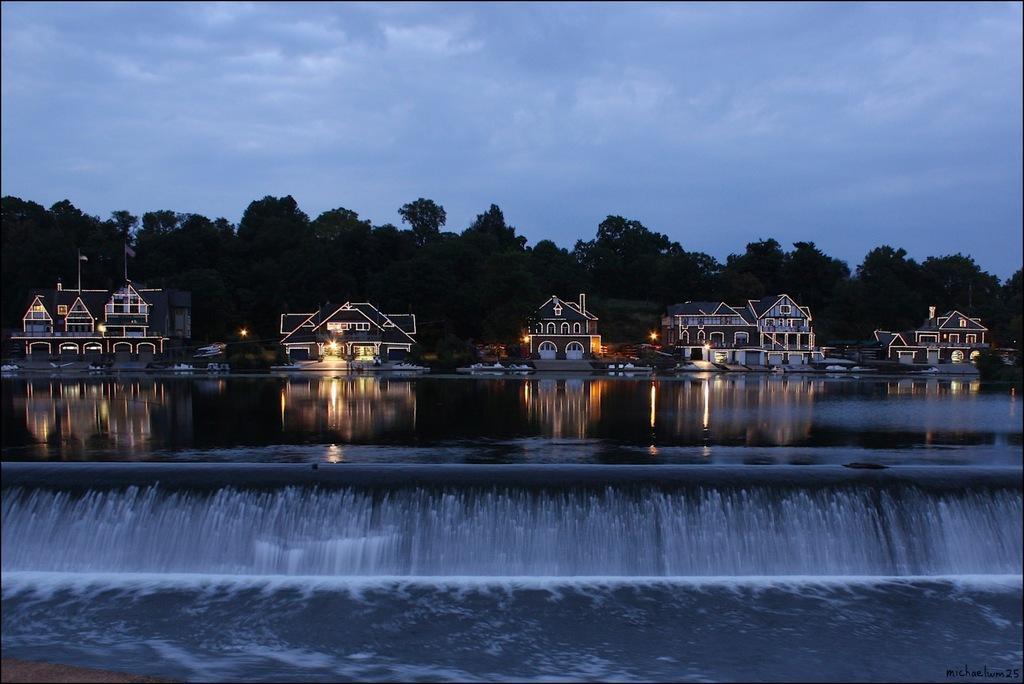Can you describe this image briefly? In the image we can see there are waves in the water and there are buildings. There are lightings in the buildings and behind there are trees. There is a cloudy sky. 